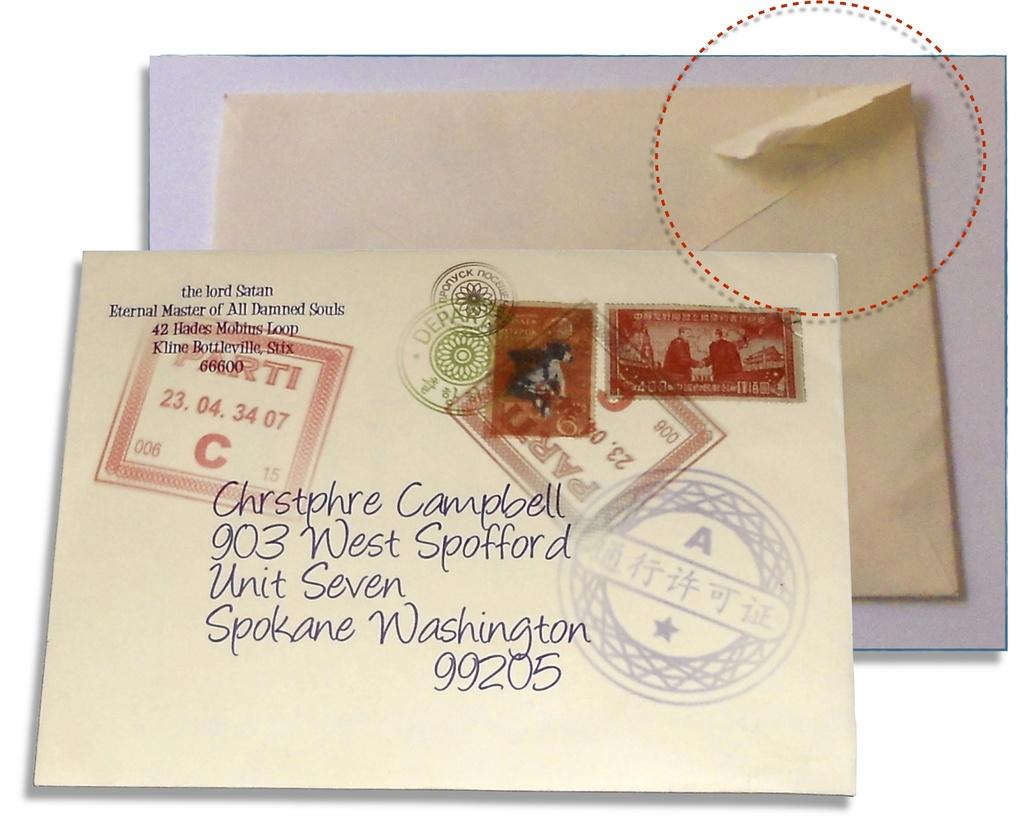<image>
Present a compact description of the photo's key features. Two envelopes one addressed to Chrstphre Cambell in Spokane, Washington with and the back of the other envelope torn in the corner. 